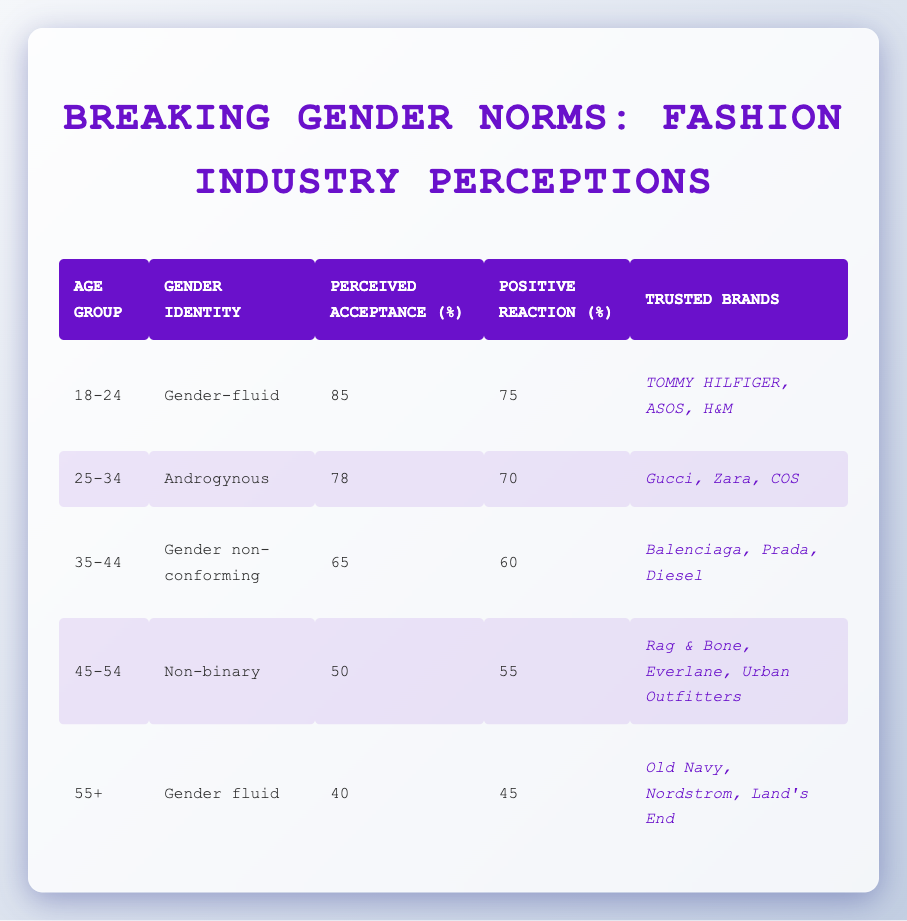What is the perceived acceptance percentage for the 18-24 age group? The table shows that the perceived acceptance for the 18-24 age group is listed directly under the 'Perceived Acceptance (%)' column, which is 85.
Answer: 85 Which gender identity corresponds to the age group 35-44? By looking at the row for the age group 35-44, we can see that the gender identity listed is 'Gender non-conforming'.
Answer: Gender non-conforming What is the average positive reaction percentage across all age groups? To find the average, we must sum the positive reaction percentages: (75 + 70 + 60 + 55 + 45) = 305. There are 5 age groups, so we divide by 5: 305/5 = 61.
Answer: 61 Are there any brands trusted by the 45-54 age group? The table provides trusted brands for different age groups, and for the 45-54 age group, the trusted brands are listed as 'Rag & Bone, Everlane, Urban Outfitters', which confirms that there are indeed trusted brands.
Answer: Yes Which age group has the lowest perceived acceptance percentage? Assessing the perceived acceptance values in the table, the age group 55+ has the lowest percentage at 40.
Answer: 55+ What is the difference in perceived acceptance between the age groups 25-34 and 35-44? The perceived acceptance for the 25-34 age group is 78 and for the 35-44 age group is 65. The difference is calculated as 78 - 65, which equals 13.
Answer: 13 Which trusted brand appears for both the 18-24 and 25-34 age groups? The trusted brands for 18-24 are 'TOMMY HILFIGER, ASOS, H&M' and for 25-34 are 'Gucci, Zara, COS'. Comparing the lists, there are no overlapping brands.
Answer: No What is the average perceived acceptance for all age groups 45 and older? The relevant age groups are 45-54 and 55+. The perceived acceptance values for these groups are 50 and 40, respectively. Summing these gives 50 + 40 = 90, and dividing by 2 gives an average of 45.
Answer: 45 Is the positive reaction percentage higher for the 35-44 age group than for the 45-54 age group? The positive reaction percentage for 35-44 is 60, and for 45-54 it is 55. Since 60 is greater than 55, we conclude that the reaction percentage is indeed higher for the 35-44 age group.
Answer: Yes 